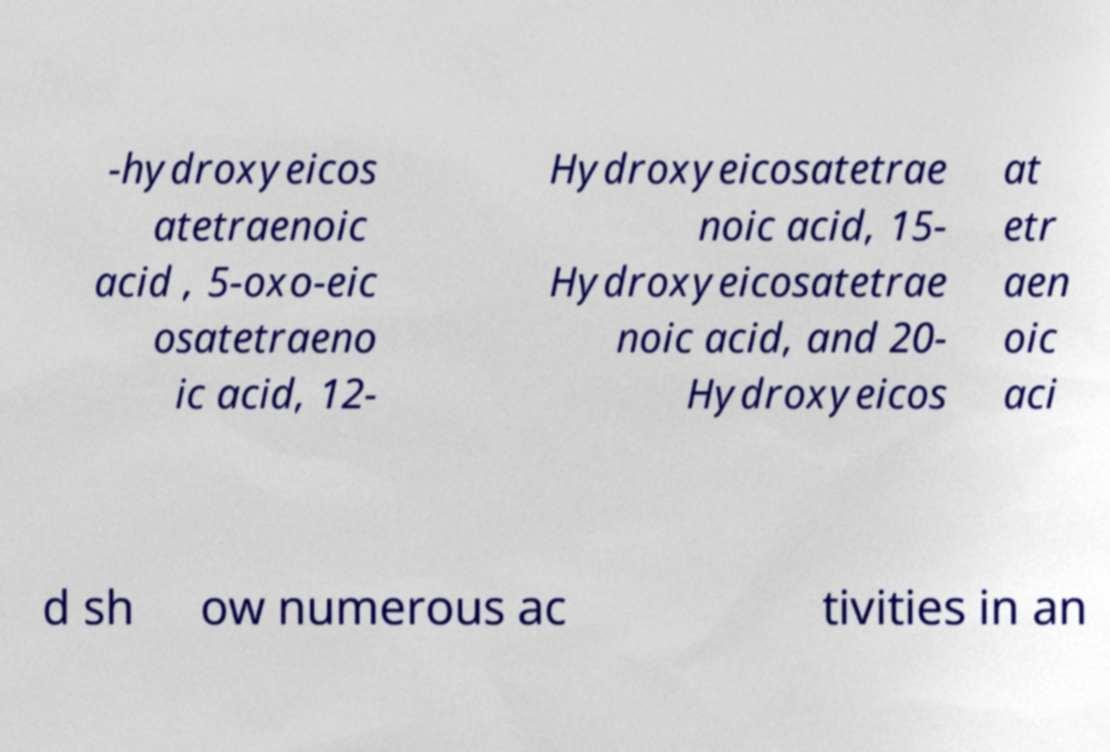Could you assist in decoding the text presented in this image and type it out clearly? -hydroxyeicos atetraenoic acid , 5-oxo-eic osatetraeno ic acid, 12- Hydroxyeicosatetrae noic acid, 15- Hydroxyeicosatetrae noic acid, and 20- Hydroxyeicos at etr aen oic aci d sh ow numerous ac tivities in an 